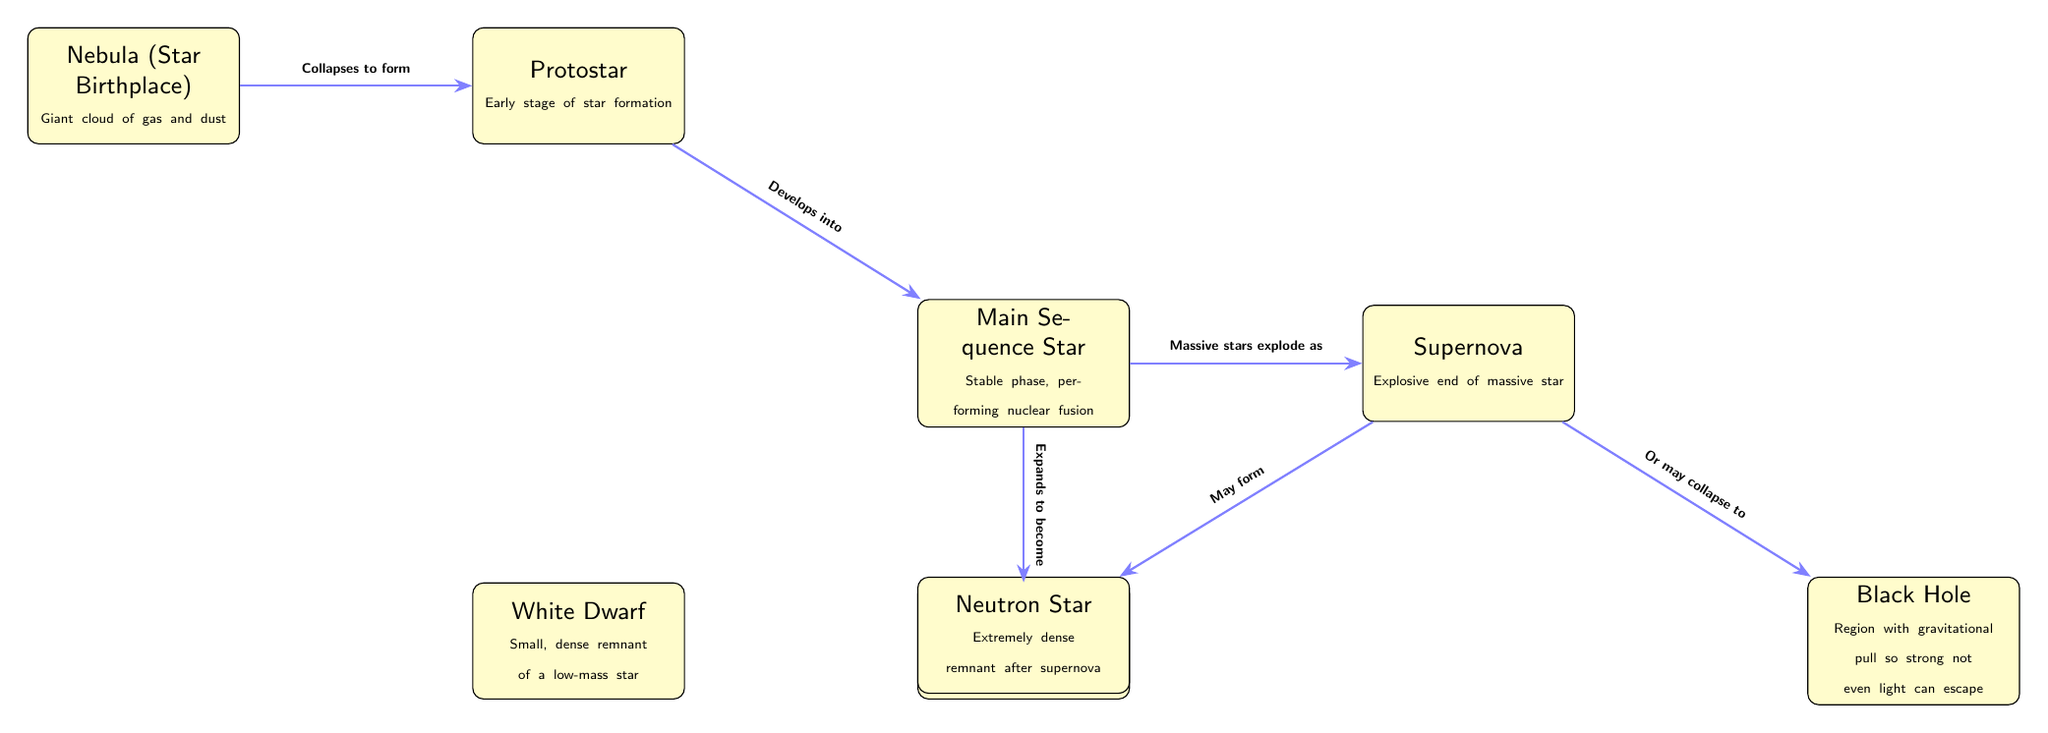What is the first stage in a star's lifecycle? The diagram indicates "Nebula" as the first stage, where it describes a giant cloud of gas and dust that serves as a star's birthplace.
Answer: Nebula Which star stage is known for nuclear fusion? The "Main Sequence Star" node explicitly states that it is the stable phase where the star performs nuclear fusion, highlighting its essential function in stellar lifecycle.
Answer: Main Sequence Star How many final stages are identified for a massive star? The diagram shows two potential endpoints for a massive star after a supernova: "Neutron Star" and "Black Hole," leading to the conclusion that there are two identified stages.
Answer: 2 What happens to a red giant at the end of its lifecycle? According to the diagram, a red giant "Sheds outer layers, leaving behind" a "White Dwarf," providing a clear path in the lifecycle that results in this specific outcome.
Answer: White Dwarf What follows after a protostar develops? The connection in the diagram indicates that the "Protostar" develops into the "Main Sequence Star," making it the next logical stage in stellar evolution.
Answer: Main Sequence Star What do massive stars explode as? The diagram clearly states that "Massive stars explode as" a "Supernova," indicating the explosive transformation of these stars in their final stages.
Answer: Supernova What is created after a supernova? The diagram presents two options after a supernova: a "Neutron Star" or a "Black Hole," signifying distinct types of remnants from this explosive event.
Answer: Neutron Star or Black Hole What is the last stage of a low-mass star as per the diagram? The final stage of a low-mass star is shown as "White Dwarf," which is noted in the diagram as the remnant after a red giant sheds its outer layers.
Answer: White Dwarf In which star lifecycle stage do cooling outer layers occur? The "Red Giant" phase is explicitly noted in the diagram for having "Expanded, cooling outer layers," thus identifying the stage where this cooling occurs.
Answer: Red Giant 